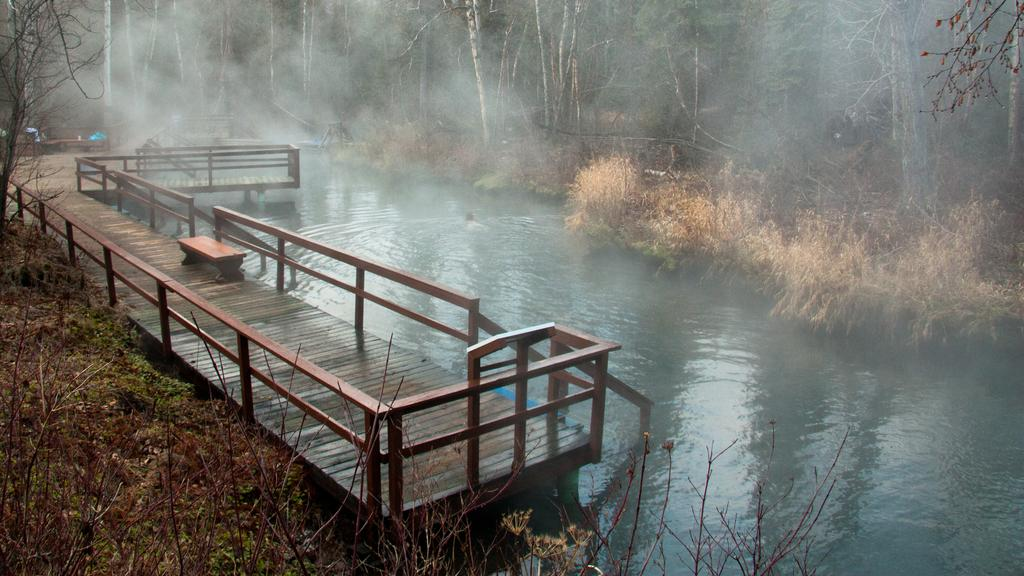What structure is present in the image? There is a bridge in the image. What can be seen in the background of the image? There is water and trees with green color visible in the background of the image. Where is the can located in the image? There is no can present in the image. What type of airport can be seen in the image? There is no airport present in the image. 